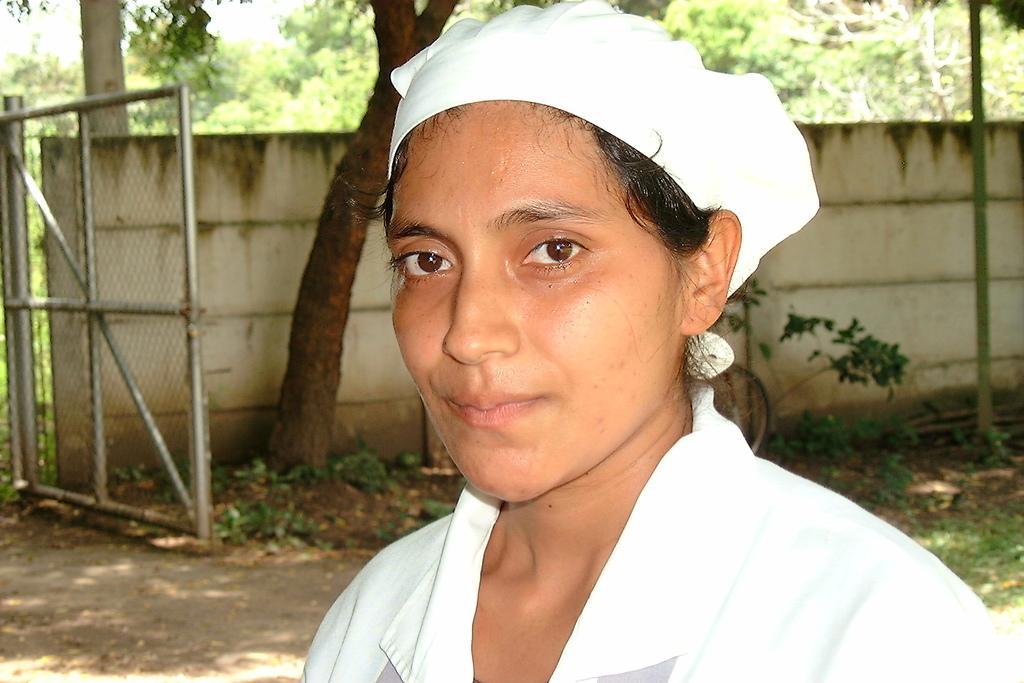Please provide a concise description of this image. In this image we can see a woman and behind her we can see trees, plants, wall and metal object. 